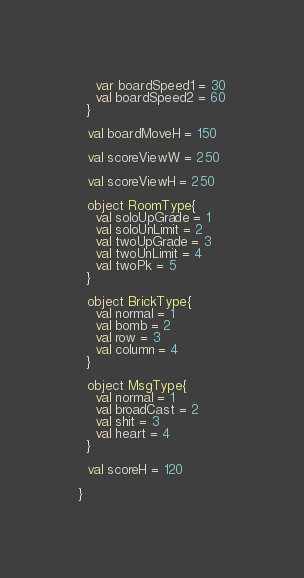Convert code to text. <code><loc_0><loc_0><loc_500><loc_500><_Scala_>    var boardSpeed1 = 30
    val boardSpeed2 = 60
  }

  val boardMoveH = 150

  val scoreViewW = 250

  val scoreViewH = 250

  object RoomType{
    val soloUpGrade = 1
    val soloUnLimit = 2
    val twoUpGrade = 3
    val twoUnLimit = 4
    val twoPk = 5
  }

  object BrickType{
    val normal = 1
    val bomb = 2
    val row = 3
    val column = 4
  }

  object MsgType{
    val normal = 1
    val broadCast = 2
    val shit = 3
    val heart = 4
  }

  val scoreH = 120

}
</code> 